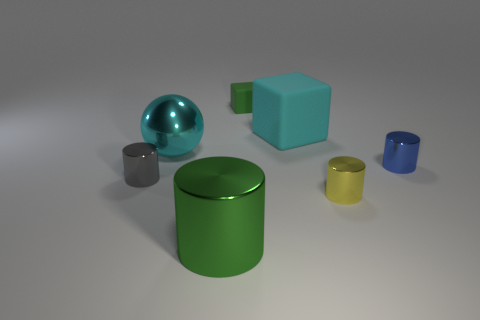How would you describe the composition of this image? The composition is minimalistic with a balanced arrangement of geometric shapes. The objects are spaced out evenly against a neutral background, creating a sense of order and simplicity. 